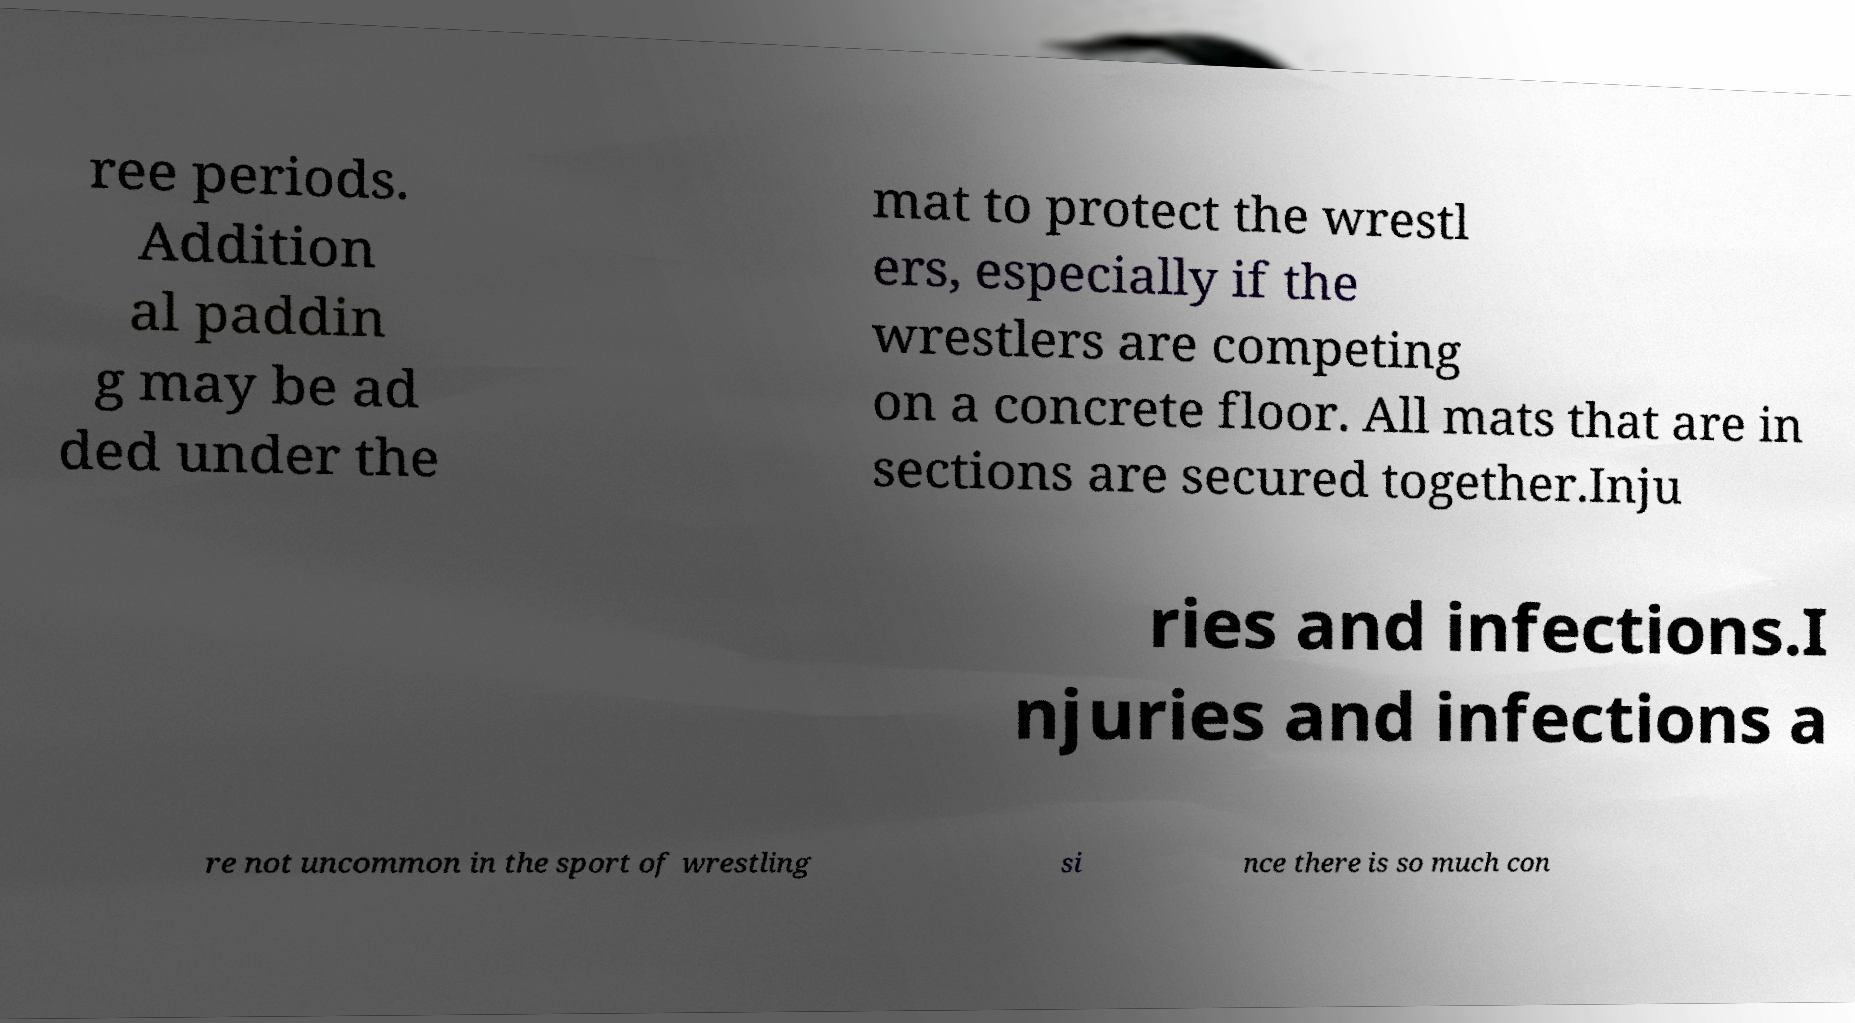What messages or text are displayed in this image? I need them in a readable, typed format. ree periods. Addition al paddin g may be ad ded under the mat to protect the wrestl ers, especially if the wrestlers are competing on a concrete floor. All mats that are in sections are secured together.Inju ries and infections.I njuries and infections a re not uncommon in the sport of wrestling si nce there is so much con 